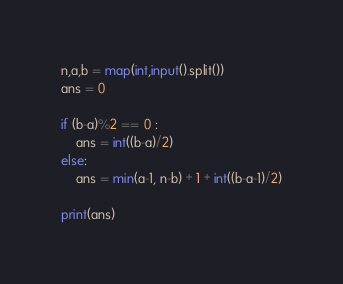<code> <loc_0><loc_0><loc_500><loc_500><_Python_>n,a,b = map(int,input().split())
ans = 0

if (b-a)%2 == 0 :
    ans = int((b-a)/2)
else:
    ans = min(a-1, n-b) + 1 + int((b-a-1)/2)

print(ans)</code> 